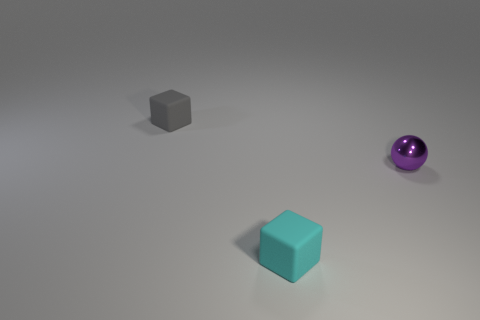Add 3 tiny gray rubber objects. How many objects exist? 6 Subtract all cubes. How many objects are left? 1 Subtract all cyan matte things. Subtract all purple things. How many objects are left? 1 Add 1 small gray objects. How many small gray objects are left? 2 Add 2 tiny purple objects. How many tiny purple objects exist? 3 Subtract 0 red blocks. How many objects are left? 3 